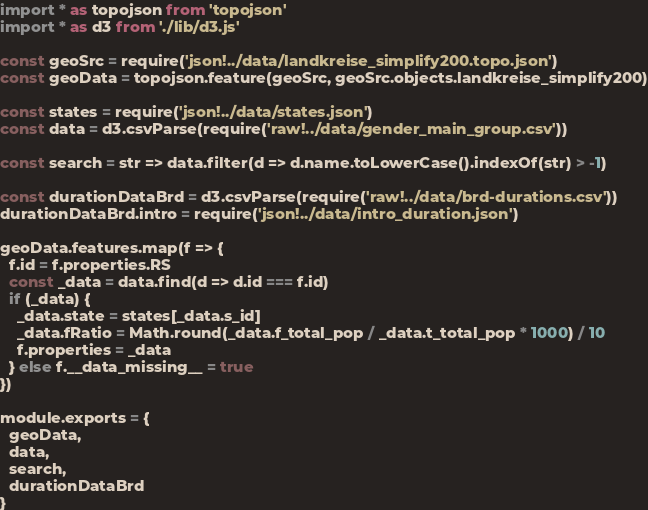<code> <loc_0><loc_0><loc_500><loc_500><_JavaScript_>import * as topojson from 'topojson'
import * as d3 from './lib/d3.js'

const geoSrc = require('json!../data/landkreise_simplify200.topo.json')
const geoData = topojson.feature(geoSrc, geoSrc.objects.landkreise_simplify200)

const states = require('json!../data/states.json')
const data = d3.csvParse(require('raw!../data/gender_main_group.csv'))

const search = str => data.filter(d => d.name.toLowerCase().indexOf(str) > -1)

const durationDataBrd = d3.csvParse(require('raw!../data/brd-durations.csv'))
durationDataBrd.intro = require('json!../data/intro_duration.json')

geoData.features.map(f => {
  f.id = f.properties.RS
  const _data = data.find(d => d.id === f.id)
  if (_data) {
    _data.state = states[_data.s_id]
    _data.fRatio = Math.round(_data.f_total_pop / _data.t_total_pop * 1000) / 10
    f.properties = _data
  } else f.__data_missing__ = true
})

module.exports = {
  geoData,
  data,
  search,
  durationDataBrd
}

</code> 